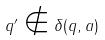<formula> <loc_0><loc_0><loc_500><loc_500>q ^ { \prime } \notin \delta ( q , a )</formula> 